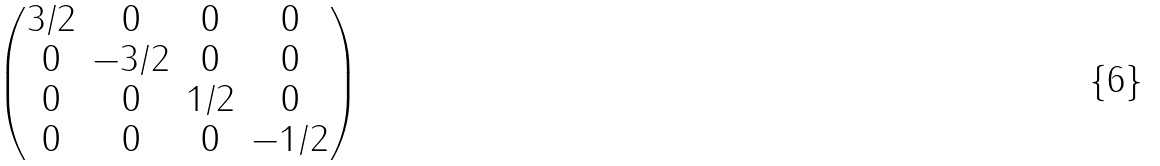Convert formula to latex. <formula><loc_0><loc_0><loc_500><loc_500>\begin{pmatrix} 3 / 2 & 0 & 0 & 0 \\ 0 & - 3 / 2 & 0 & 0 \\ 0 & 0 & 1 / 2 & 0 \\ 0 & 0 & 0 & - 1 / 2 \\ \end{pmatrix}</formula> 